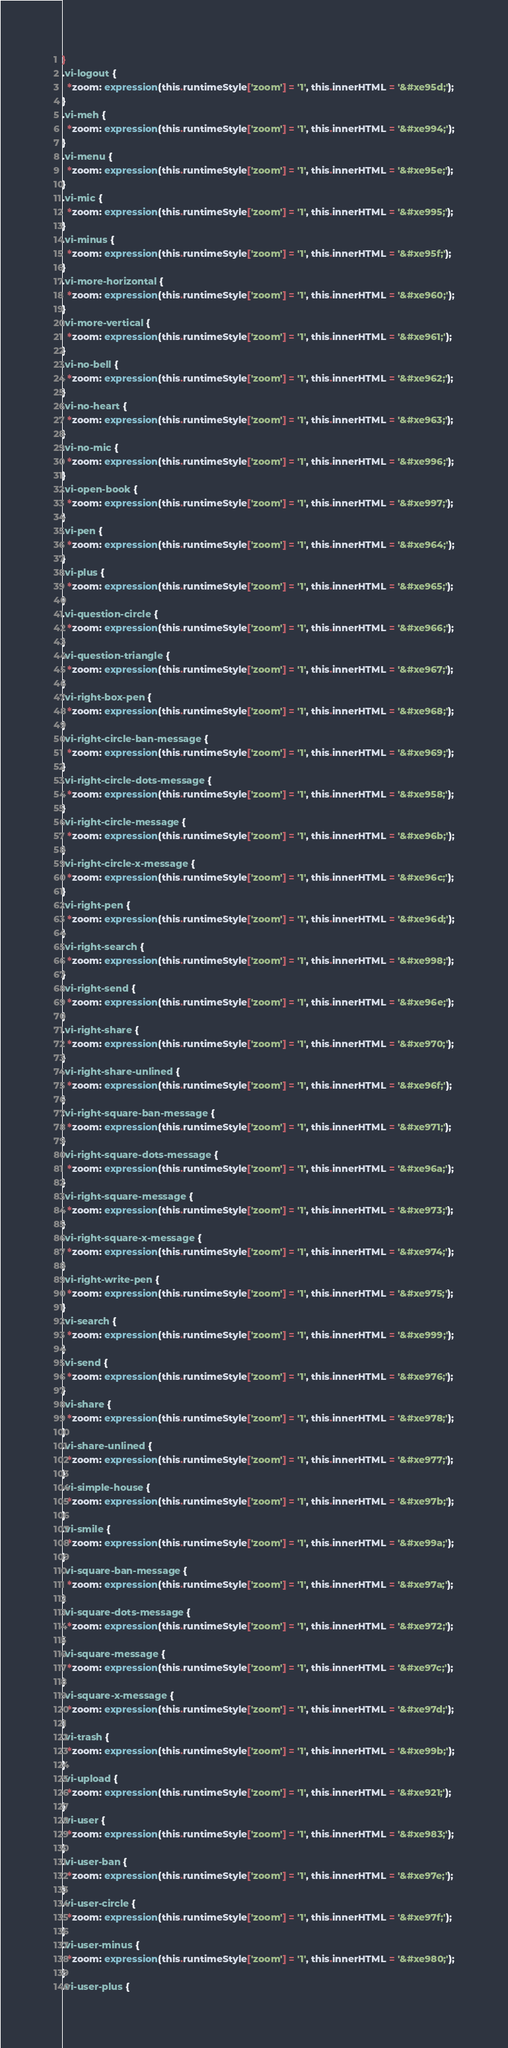<code> <loc_0><loc_0><loc_500><loc_500><_CSS_>}
.vi-logout {
  *zoom: expression(this.runtimeStyle['zoom'] = '1', this.innerHTML = '&#xe95d;');
}
.vi-meh {
  *zoom: expression(this.runtimeStyle['zoom'] = '1', this.innerHTML = '&#xe994;');
}
.vi-menu {
  *zoom: expression(this.runtimeStyle['zoom'] = '1', this.innerHTML = '&#xe95e;');
}
.vi-mic {
  *zoom: expression(this.runtimeStyle['zoom'] = '1', this.innerHTML = '&#xe995;');
}
.vi-minus {
  *zoom: expression(this.runtimeStyle['zoom'] = '1', this.innerHTML = '&#xe95f;');
}
.vi-more-horizontal {
  *zoom: expression(this.runtimeStyle['zoom'] = '1', this.innerHTML = '&#xe960;');
}
.vi-more-vertical {
  *zoom: expression(this.runtimeStyle['zoom'] = '1', this.innerHTML = '&#xe961;');
}
.vi-no-bell {
  *zoom: expression(this.runtimeStyle['zoom'] = '1', this.innerHTML = '&#xe962;');
}
.vi-no-heart {
  *zoom: expression(this.runtimeStyle['zoom'] = '1', this.innerHTML = '&#xe963;');
}
.vi-no-mic {
  *zoom: expression(this.runtimeStyle['zoom'] = '1', this.innerHTML = '&#xe996;');
}
.vi-open-book {
  *zoom: expression(this.runtimeStyle['zoom'] = '1', this.innerHTML = '&#xe997;');
}
.vi-pen {
  *zoom: expression(this.runtimeStyle['zoom'] = '1', this.innerHTML = '&#xe964;');
}
.vi-plus {
  *zoom: expression(this.runtimeStyle['zoom'] = '1', this.innerHTML = '&#xe965;');
}
.vi-question-circle {
  *zoom: expression(this.runtimeStyle['zoom'] = '1', this.innerHTML = '&#xe966;');
}
.vi-question-triangle {
  *zoom: expression(this.runtimeStyle['zoom'] = '1', this.innerHTML = '&#xe967;');
}
.vi-right-box-pen {
  *zoom: expression(this.runtimeStyle['zoom'] = '1', this.innerHTML = '&#xe968;');
}
.vi-right-circle-ban-message {
  *zoom: expression(this.runtimeStyle['zoom'] = '1', this.innerHTML = '&#xe969;');
}
.vi-right-circle-dots-message {
  *zoom: expression(this.runtimeStyle['zoom'] = '1', this.innerHTML = '&#xe958;');
}
.vi-right-circle-message {
  *zoom: expression(this.runtimeStyle['zoom'] = '1', this.innerHTML = '&#xe96b;');
}
.vi-right-circle-x-message {
  *zoom: expression(this.runtimeStyle['zoom'] = '1', this.innerHTML = '&#xe96c;');
}
.vi-right-pen {
  *zoom: expression(this.runtimeStyle['zoom'] = '1', this.innerHTML = '&#xe96d;');
}
.vi-right-search {
  *zoom: expression(this.runtimeStyle['zoom'] = '1', this.innerHTML = '&#xe998;');
}
.vi-right-send {
  *zoom: expression(this.runtimeStyle['zoom'] = '1', this.innerHTML = '&#xe96e;');
}
.vi-right-share {
  *zoom: expression(this.runtimeStyle['zoom'] = '1', this.innerHTML = '&#xe970;');
}
.vi-right-share-unlined {
  *zoom: expression(this.runtimeStyle['zoom'] = '1', this.innerHTML = '&#xe96f;');
}
.vi-right-square-ban-message {
  *zoom: expression(this.runtimeStyle['zoom'] = '1', this.innerHTML = '&#xe971;');
}
.vi-right-square-dots-message {
  *zoom: expression(this.runtimeStyle['zoom'] = '1', this.innerHTML = '&#xe96a;');
}
.vi-right-square-message {
  *zoom: expression(this.runtimeStyle['zoom'] = '1', this.innerHTML = '&#xe973;');
}
.vi-right-square-x-message {
  *zoom: expression(this.runtimeStyle['zoom'] = '1', this.innerHTML = '&#xe974;');
}
.vi-right-write-pen {
  *zoom: expression(this.runtimeStyle['zoom'] = '1', this.innerHTML = '&#xe975;');
}
.vi-search {
  *zoom: expression(this.runtimeStyle['zoom'] = '1', this.innerHTML = '&#xe999;');
}
.vi-send {
  *zoom: expression(this.runtimeStyle['zoom'] = '1', this.innerHTML = '&#xe976;');
}
.vi-share {
  *zoom: expression(this.runtimeStyle['zoom'] = '1', this.innerHTML = '&#xe978;');
}
.vi-share-unlined {
  *zoom: expression(this.runtimeStyle['zoom'] = '1', this.innerHTML = '&#xe977;');
}
.vi-simple-house {
  *zoom: expression(this.runtimeStyle['zoom'] = '1', this.innerHTML = '&#xe97b;');
}
.vi-smile {
  *zoom: expression(this.runtimeStyle['zoom'] = '1', this.innerHTML = '&#xe99a;');
}
.vi-square-ban-message {
  *zoom: expression(this.runtimeStyle['zoom'] = '1', this.innerHTML = '&#xe97a;');
}
.vi-square-dots-message {
  *zoom: expression(this.runtimeStyle['zoom'] = '1', this.innerHTML = '&#xe972;');
}
.vi-square-message {
  *zoom: expression(this.runtimeStyle['zoom'] = '1', this.innerHTML = '&#xe97c;');
}
.vi-square-x-message {
  *zoom: expression(this.runtimeStyle['zoom'] = '1', this.innerHTML = '&#xe97d;');
}
.vi-trash {
  *zoom: expression(this.runtimeStyle['zoom'] = '1', this.innerHTML = '&#xe99b;');
}
.vi-upload {
  *zoom: expression(this.runtimeStyle['zoom'] = '1', this.innerHTML = '&#xe921;');
}
.vi-user {
  *zoom: expression(this.runtimeStyle['zoom'] = '1', this.innerHTML = '&#xe983;');
}
.vi-user-ban {
  *zoom: expression(this.runtimeStyle['zoom'] = '1', this.innerHTML = '&#xe97e;');
}
.vi-user-circle {
  *zoom: expression(this.runtimeStyle['zoom'] = '1', this.innerHTML = '&#xe97f;');
}
.vi-user-minus {
  *zoom: expression(this.runtimeStyle['zoom'] = '1', this.innerHTML = '&#xe980;');
}
.vi-user-plus {</code> 